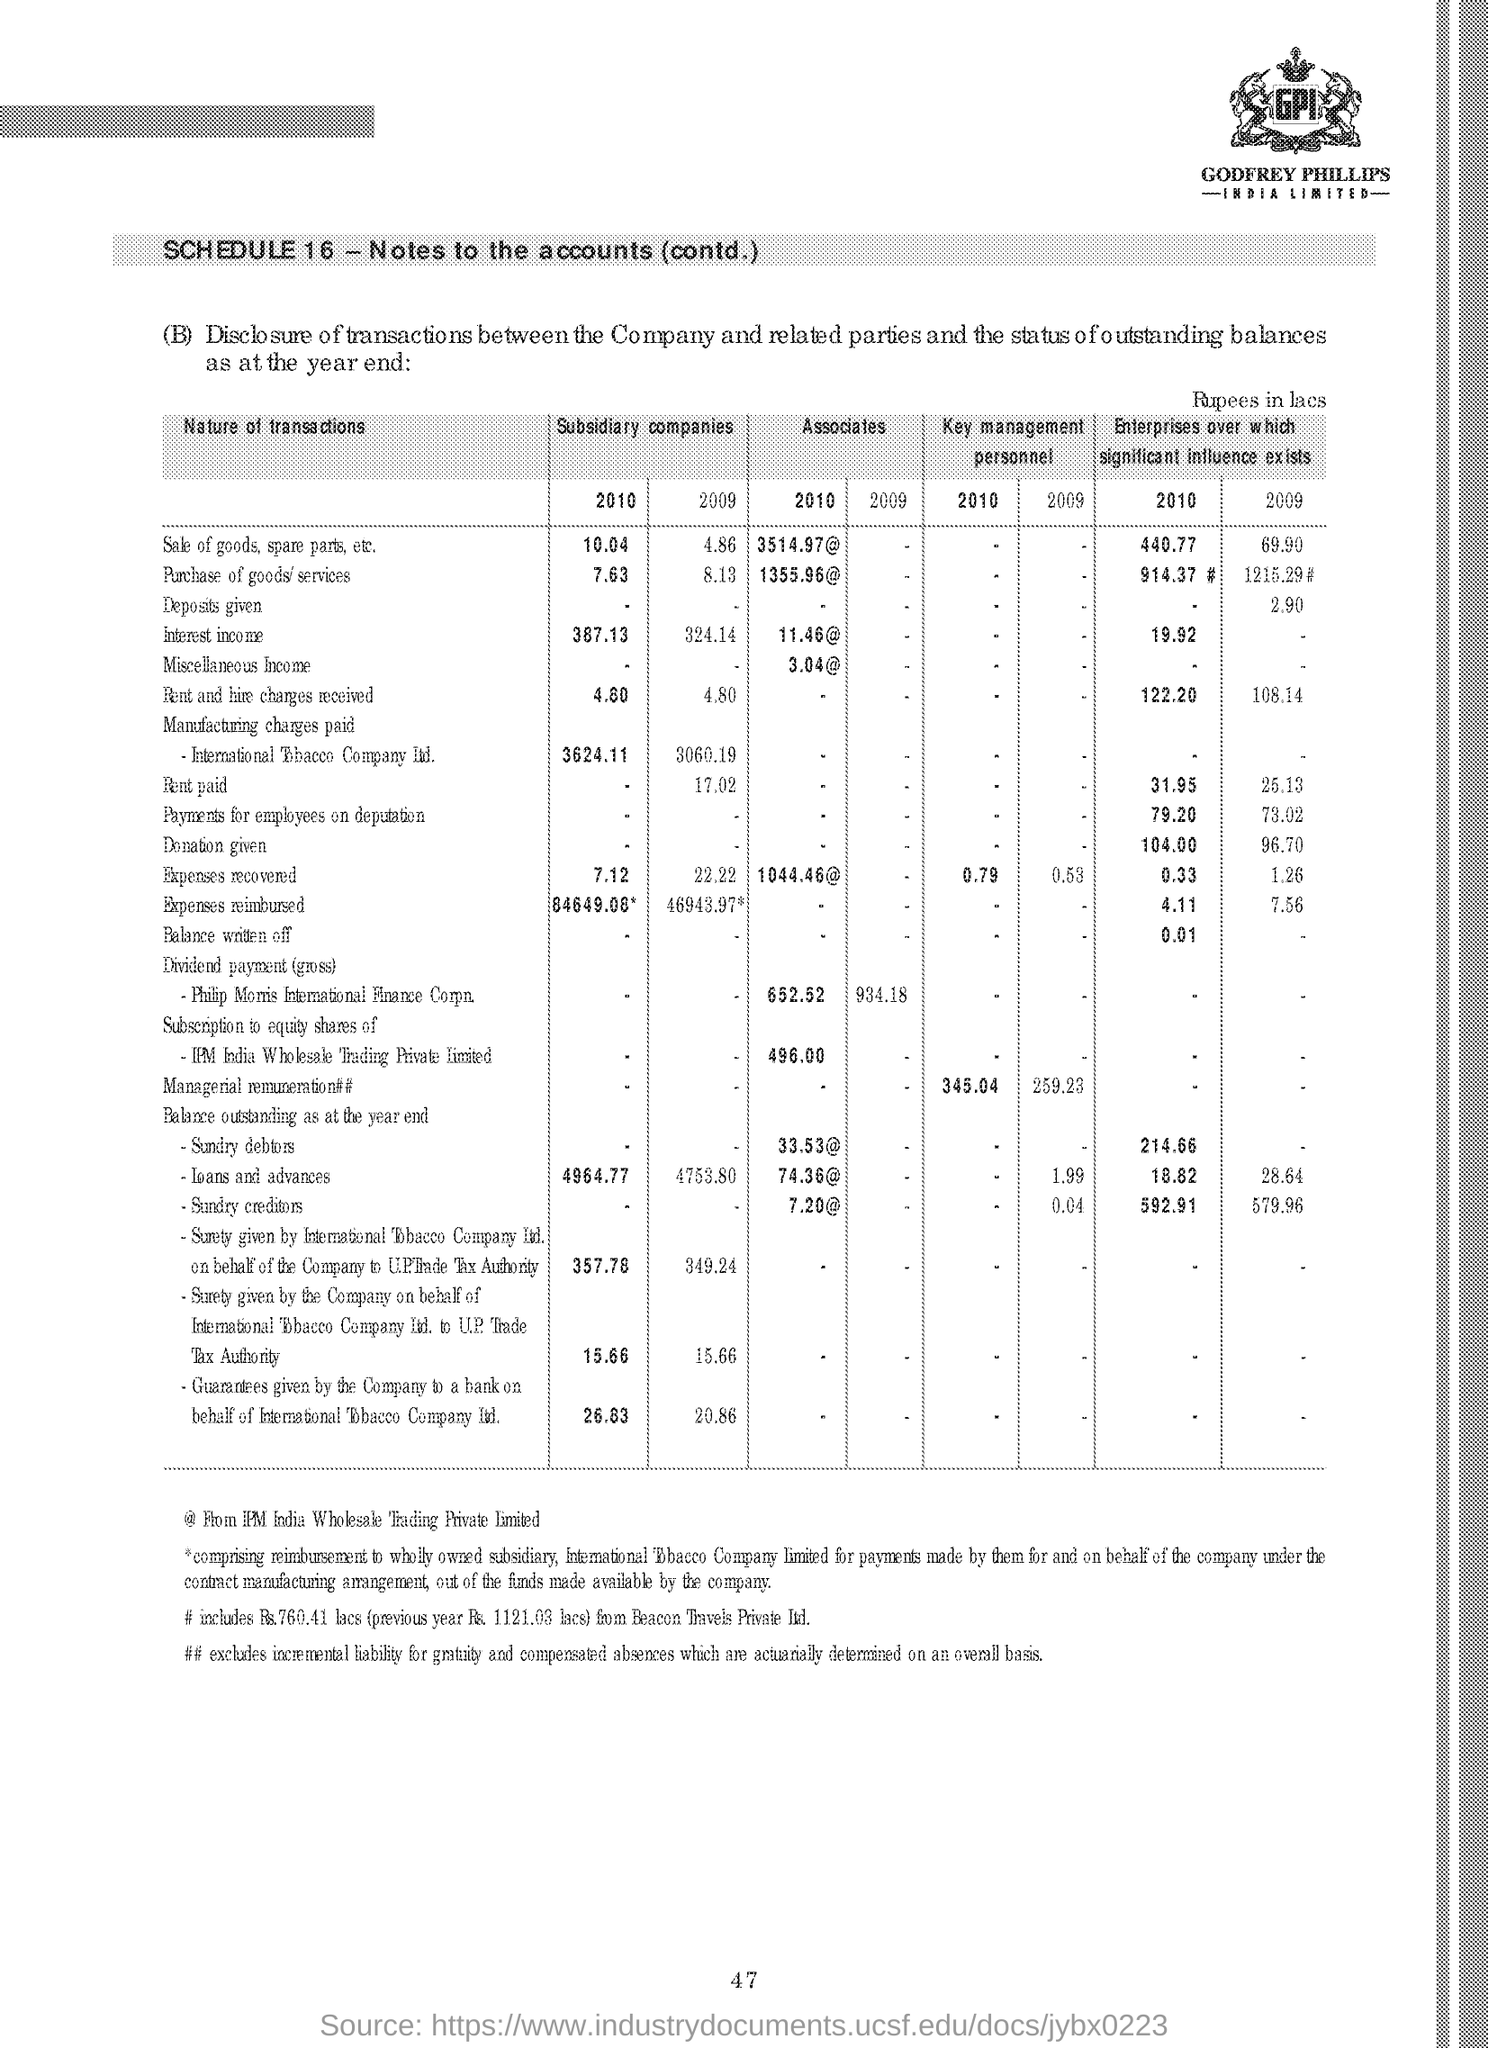Specify some key components in this picture. The logo of Godrej & Boyce Manufacturing Company Limited, an Indian multinational company, is located at the top right corner of the cover page. The sale of goods and spare parts by subsidiary companies in 2010 was $10.04. The symbol "@" refers to the email address of IPM India Wholesale Trading Private Limited. NOTES TO THE ACCOUNTS (CONTINUED), INCLUDING SCHEDULE 16, ARE AVAILABLE UPON REQUEST. The heading of the first column is "Nature of Transactions. 